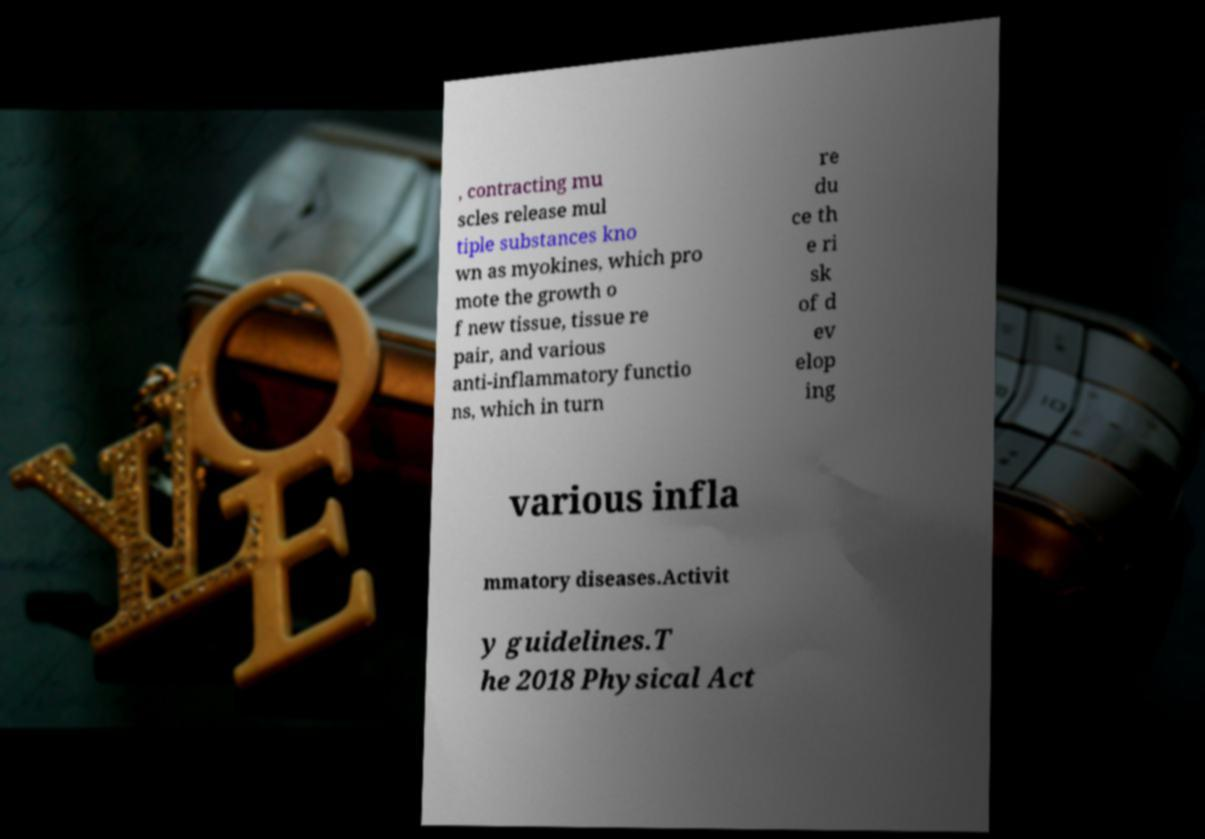Could you extract and type out the text from this image? , contracting mu scles release mul tiple substances kno wn as myokines, which pro mote the growth o f new tissue, tissue re pair, and various anti-inflammatory functio ns, which in turn re du ce th e ri sk of d ev elop ing various infla mmatory diseases.Activit y guidelines.T he 2018 Physical Act 